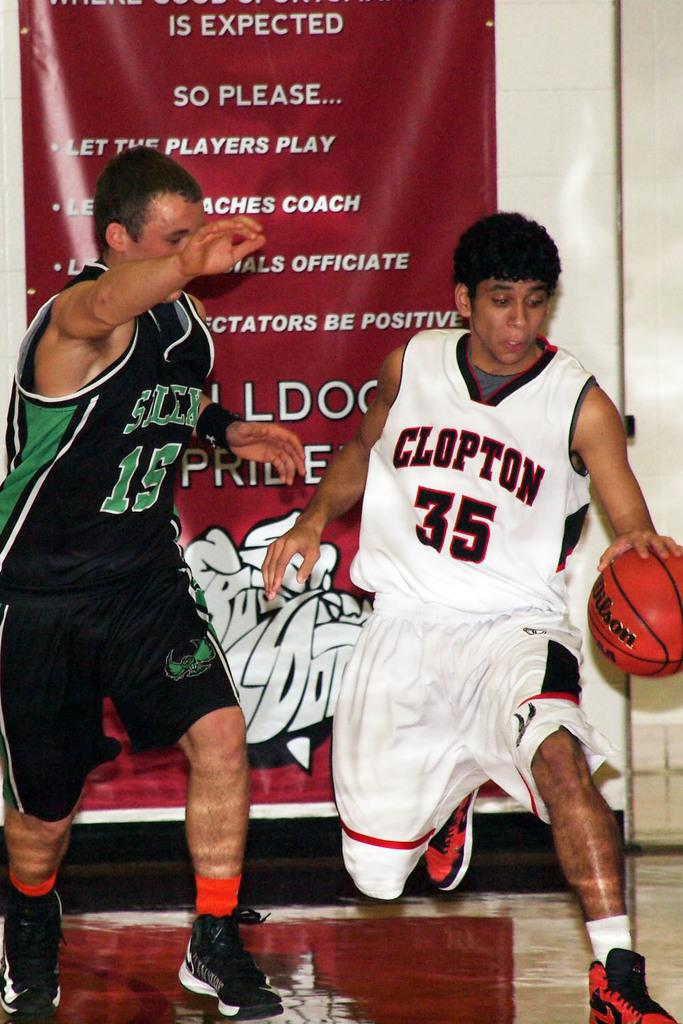<image>
Provide a brief description of the given image. two basketball players with numbers 35 and 15 on their jerseys 